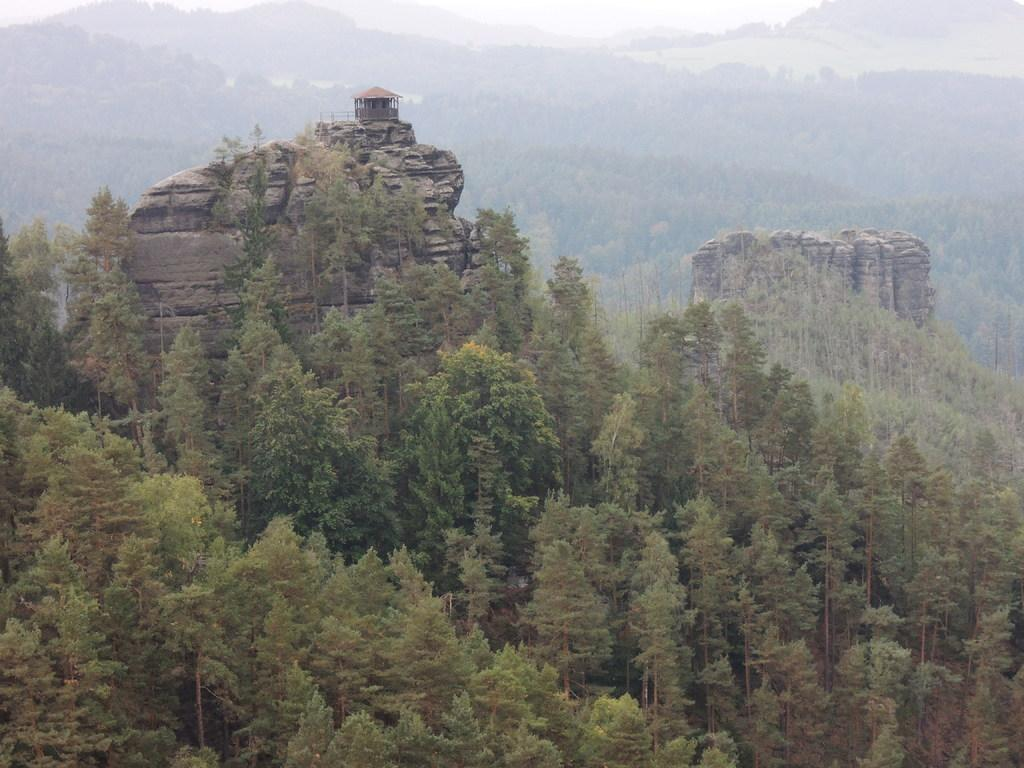What is visible in the background of the image? The sky is visible in the image. What can be seen in the sky in the image? There are clouds in the image. What type of natural landforms are present in the image? There are hills in the image. What type of vegetation is present in the image? There are trees, plants, and grass in the image. What type of rub can be seen on the cemetery in the image? There is no cemetery present in the image, and therefore no rub can be observed. What type of respect is being shown towards the trees in the image? There is no indication of respect or any other emotion being shown towards the trees in the image. 